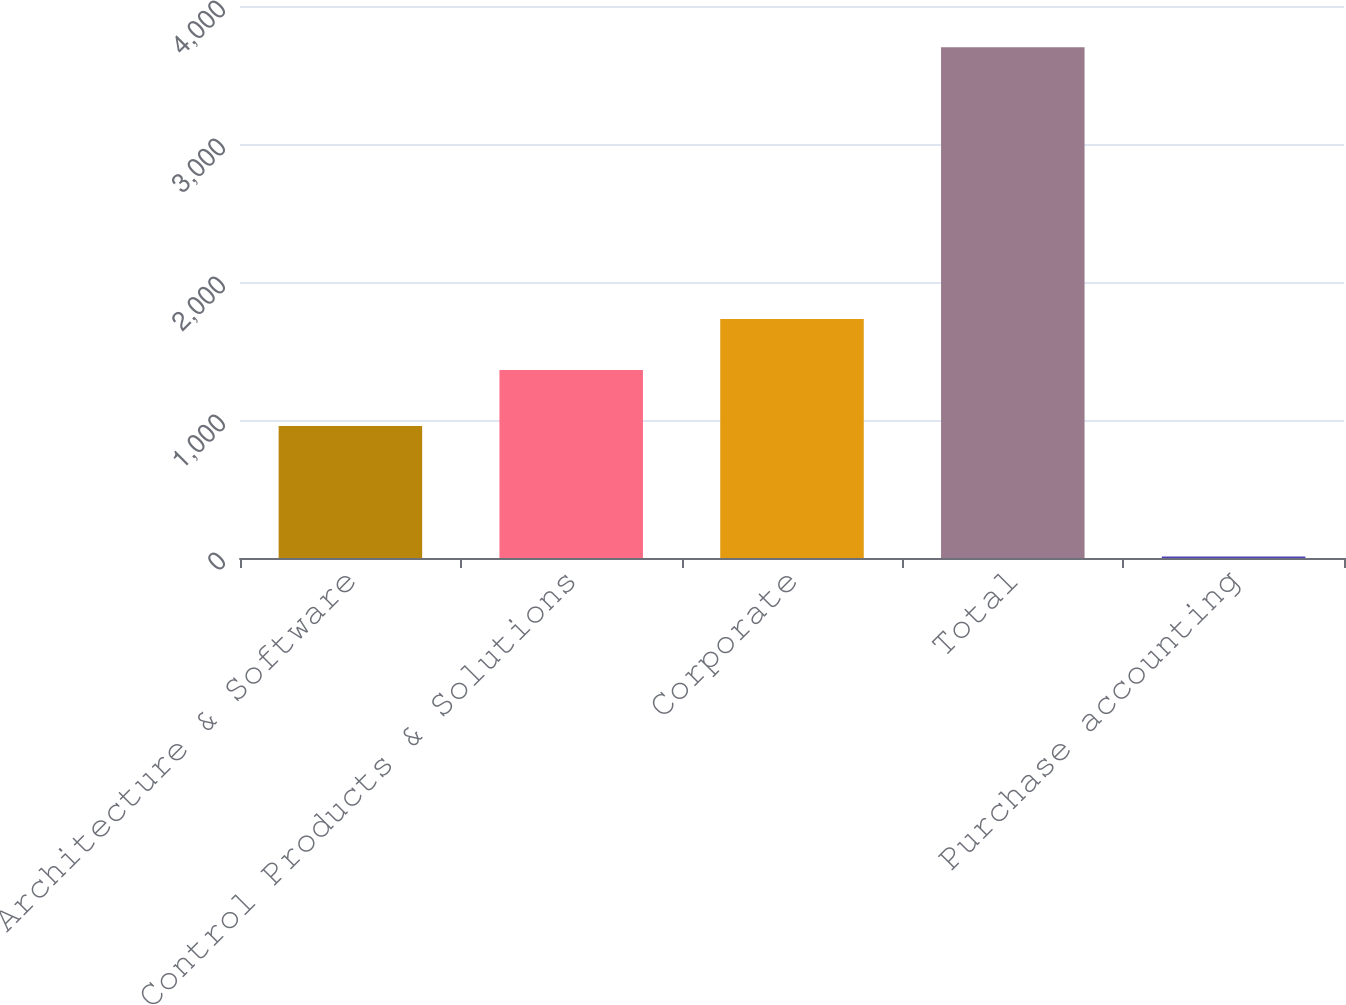<chart> <loc_0><loc_0><loc_500><loc_500><bar_chart><fcel>Architecture & Software<fcel>Control Products & Solutions<fcel>Corporate<fcel>Total<fcel>Purchase accounting<nl><fcel>956.5<fcel>1362.7<fcel>1731.79<fcel>3700.9<fcel>10<nl></chart> 